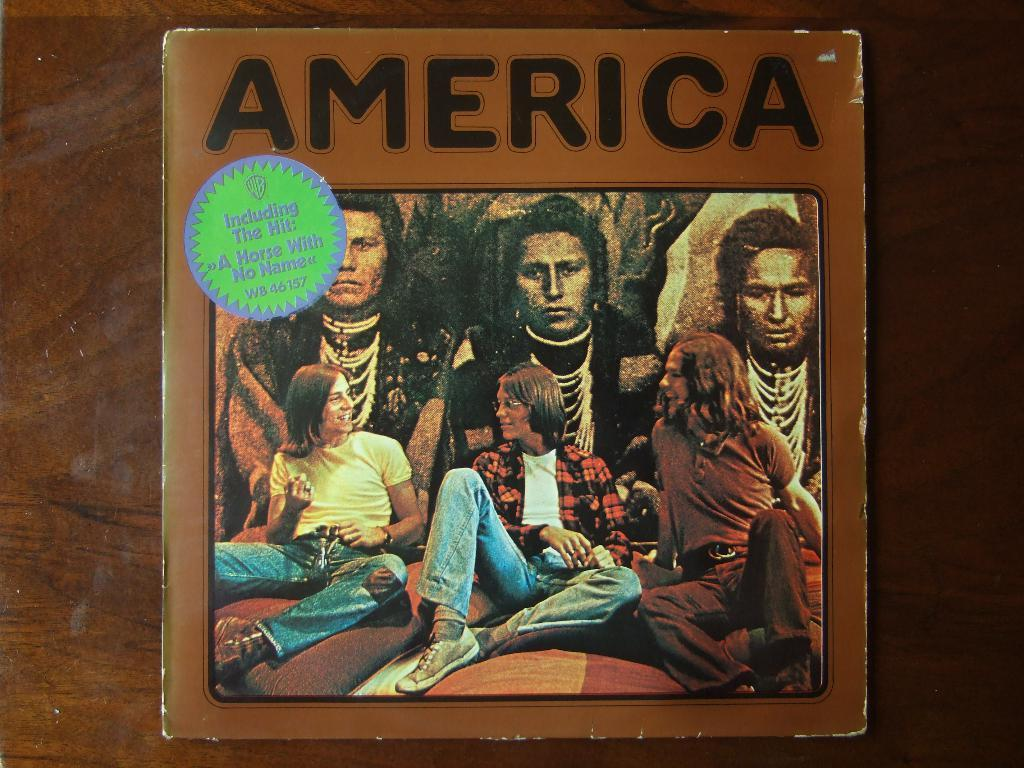<image>
Provide a brief description of the given image. an older album with the Group America and band on it. 